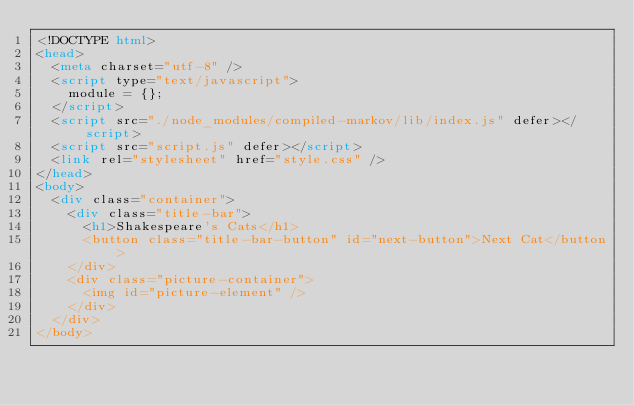Convert code to text. <code><loc_0><loc_0><loc_500><loc_500><_HTML_><!DOCTYPE html>
<head>
  <meta charset="utf-8" />
  <script type="text/javascript">
    module = {};
  </script>
  <script src="./node_modules/compiled-markov/lib/index.js" defer></script>
  <script src="script.js" defer></script>
  <link rel="stylesheet" href="style.css" />
</head>
<body>
  <div class="container">
    <div class="title-bar">
      <h1>Shakespeare's Cats</h1>
      <button class="title-bar-button" id="next-button">Next Cat</button>
    </div>
    <div class="picture-container">
      <img id="picture-element" />
    </div>
  </div>
</body>
</code> 